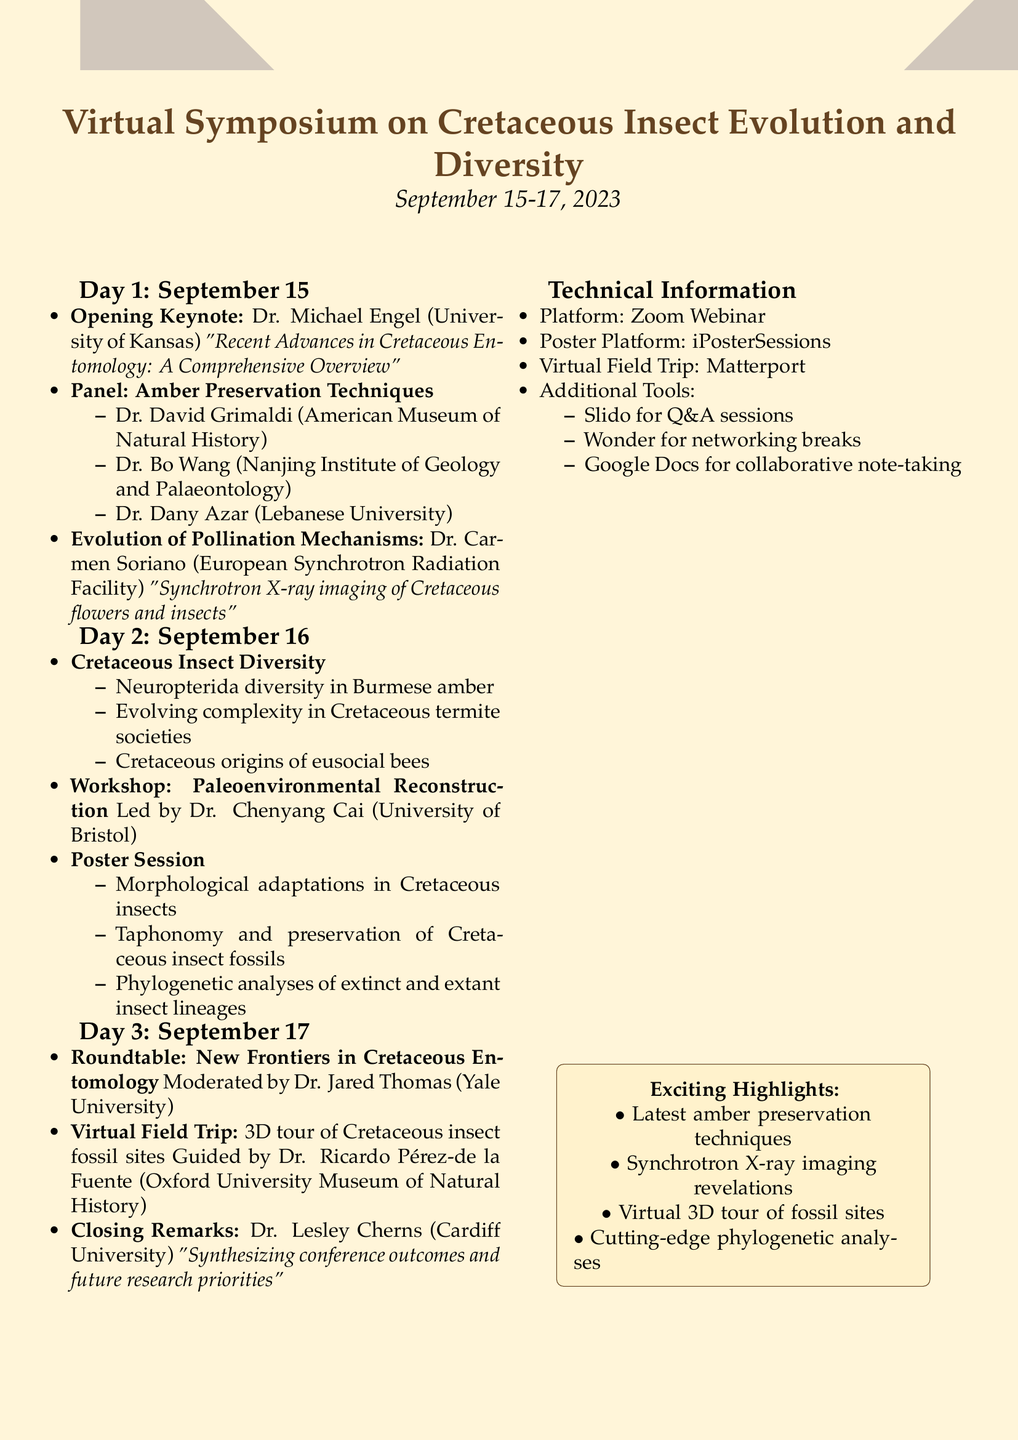What is the date range of the conference? The date range is specified at the beginning of the document, indicating when the conference will take place.
Answer: September 15-17, 2023 Who is the speaker for the Opening Keynote? The Opening Keynote section lists Dr. Michael Engel as the speaker along with his affiliation.
Answer: Dr. Michael Engel What is the title of the workshop led by Dr. Chenyang Cai? The workshop section provides the title and details about the leadership and content of the workshop.
Answer: Paleoenvironmental Reconstruction Which software will be used for the Virtual Field Trip? The technical requirements section specifies the software used for the virtual field trip experience.
Answer: Matterport What are the subtopics covered in the session on Cretaceous Insect Diversity? The session has specified subtopics that illustrate various aspects of Cretaceous insect diversity.
Answer: Neuropterida diversity in Burmese amber, Evolving complexity in Cretaceous termite societies, Cretaceous origins of eusocial bees How many panelists are involved in the Amber Preservation Techniques panel? The panel section lists the names of the panelists, leading to a count of how many are participating.
Answer: 3 Who is moderating the roundtable on New Frontiers in Cretaceous Entomology? The roundtable section identifies the moderator along with their affiliation.
Answer: Dr. Jared Thomas What is the platform used for Q&A sessions? The technical requirements state which tool will be utilized for facilitating Q&A during the conference.
Answer: Slido 